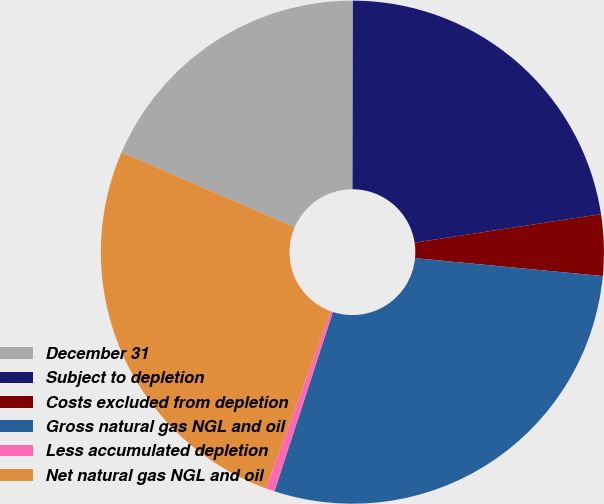Convert chart to OTSL. <chart><loc_0><loc_0><loc_500><loc_500><pie_chart><fcel>December 31<fcel>Subject to depletion<fcel>Costs excluded from depletion<fcel>Gross natural gas NGL and oil<fcel>Less accumulated depletion<fcel>Net natural gas NGL and oil<nl><fcel>18.53%<fcel>22.55%<fcel>3.93%<fcel>28.5%<fcel>0.57%<fcel>25.91%<nl></chart> 